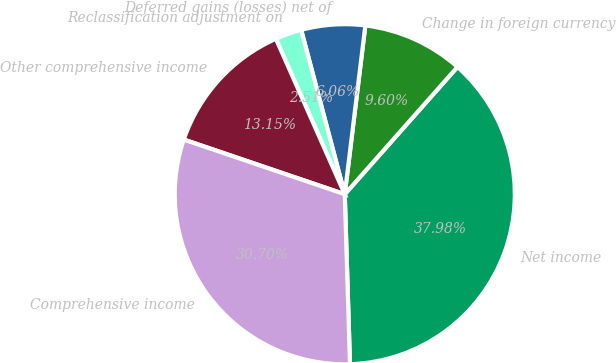Convert chart. <chart><loc_0><loc_0><loc_500><loc_500><pie_chart><fcel>Net income<fcel>Change in foreign currency<fcel>Deferred gains (losses) net of<fcel>Reclassification adjustment on<fcel>Other comprehensive income<fcel>Comprehensive income<nl><fcel>37.98%<fcel>9.6%<fcel>6.06%<fcel>2.51%<fcel>13.15%<fcel>30.7%<nl></chart> 